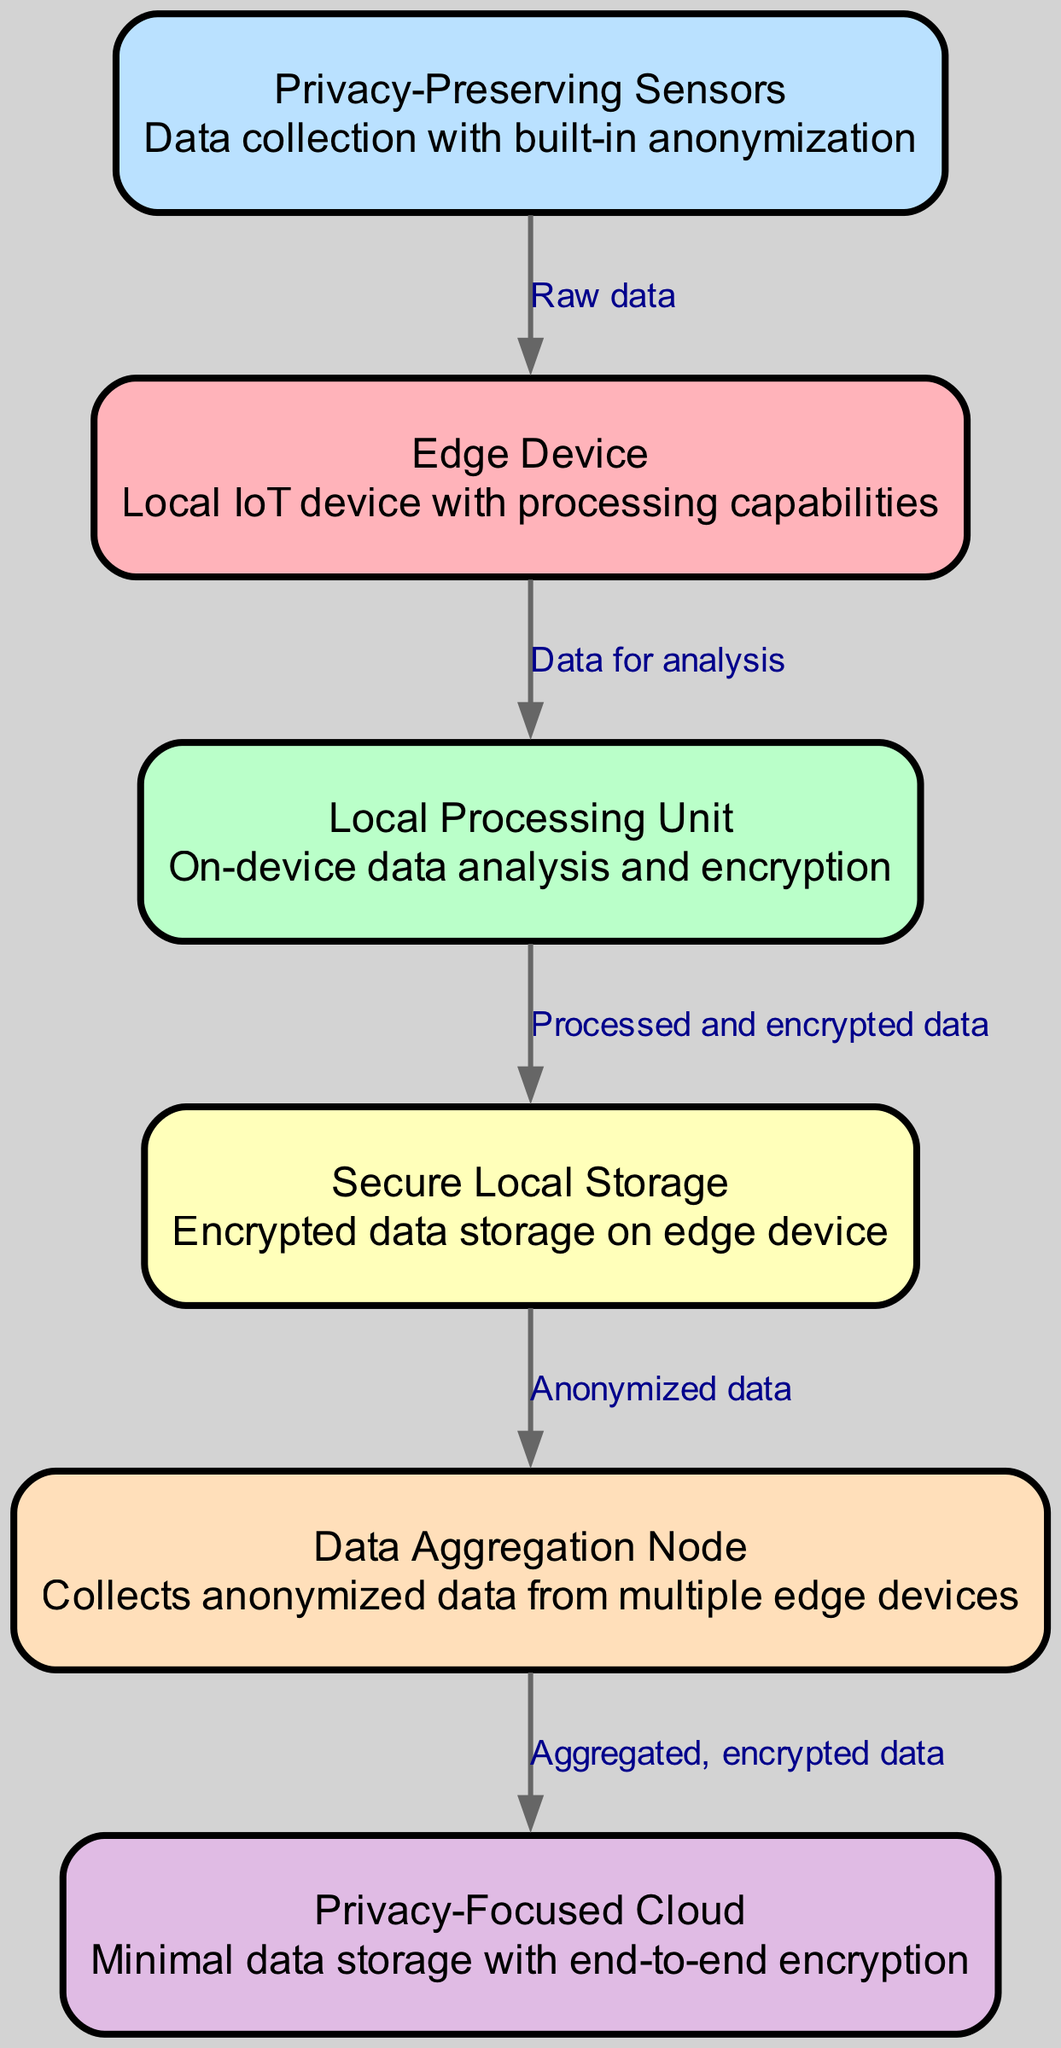What is the total number of nodes in the diagram? By counting the nodes listed in the data, we find six distinct nodes: Edge Device, Local Processing Unit, Privacy-Preserving Sensors, Secure Local Storage, Data Aggregation Node, and Privacy-Focused Cloud.
Answer: 6 What does the Edge Device connect to? The Edge Device has an outgoing connection to the Local Processing Unit as indicated by the arrow in the diagram.
Answer: Local Processing Unit Which node is responsible for data collection? The Privacy-Preserving Sensors node is directly identified as the source of raw data, making it responsible for data collection in the diagram.
Answer: Privacy-Preserving Sensors What type of data does the local processing unit produce? The local processing unit processes the incoming data and produces processed and encrypted data that is sent to the Secure Local Storage.
Answer: Processed and encrypted data What is the function of the Data Aggregation Node? The Data Aggregation Node collects anonymized data from multiple edge devices, which is indicated by the flow of data directed towards it from local storage.
Answer: Collects anonymized data Which node has secure encrypted storage? The Secure Local Storage node is explicitly identified as providing encrypted data storage on the edge device, indicating its function in the diagram.
Answer: Secure Local Storage How many edges are there in total? By counting the edges in the provided data, we see there are five connections: from sensors to edge device, edge device to local processing, local processing to local storage, local storage to aggregation node, and aggregation node to cloud.
Answer: 5 What type of cloud is depicted in the diagram? The diagram clearly refers to the cloud as a Privacy-Focused Cloud, indicating its emphasis on minimal data storage and end-to-end encryption.
Answer: Privacy-Focused Cloud What data does the aggregation node send to the cloud? The aggregation node sends the aggregated, encrypted data to the cloud as shown in the connection labeled with that description in the diagram.
Answer: Aggregated, encrypted data 